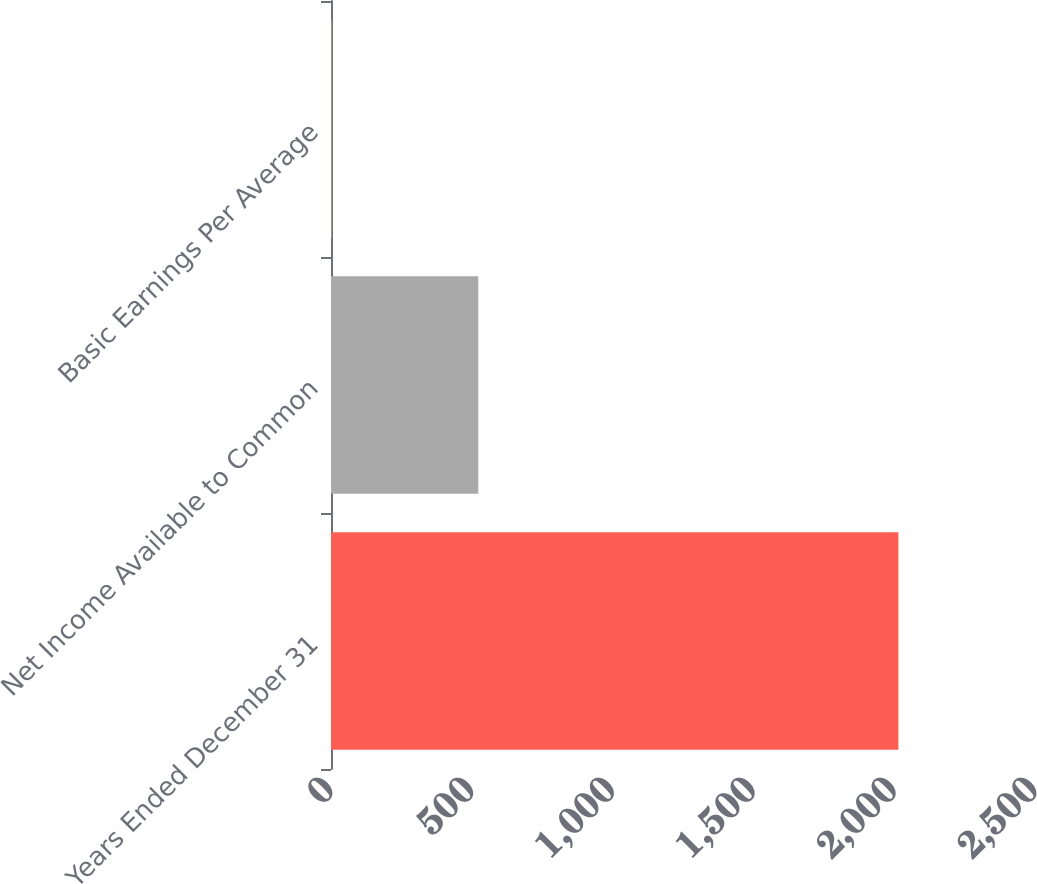Convert chart to OTSL. <chart><loc_0><loc_0><loc_500><loc_500><bar_chart><fcel>Years Ended December 31<fcel>Net Income Available to Common<fcel>Basic Earnings Per Average<nl><fcel>2015<fcel>523<fcel>1.9<nl></chart> 